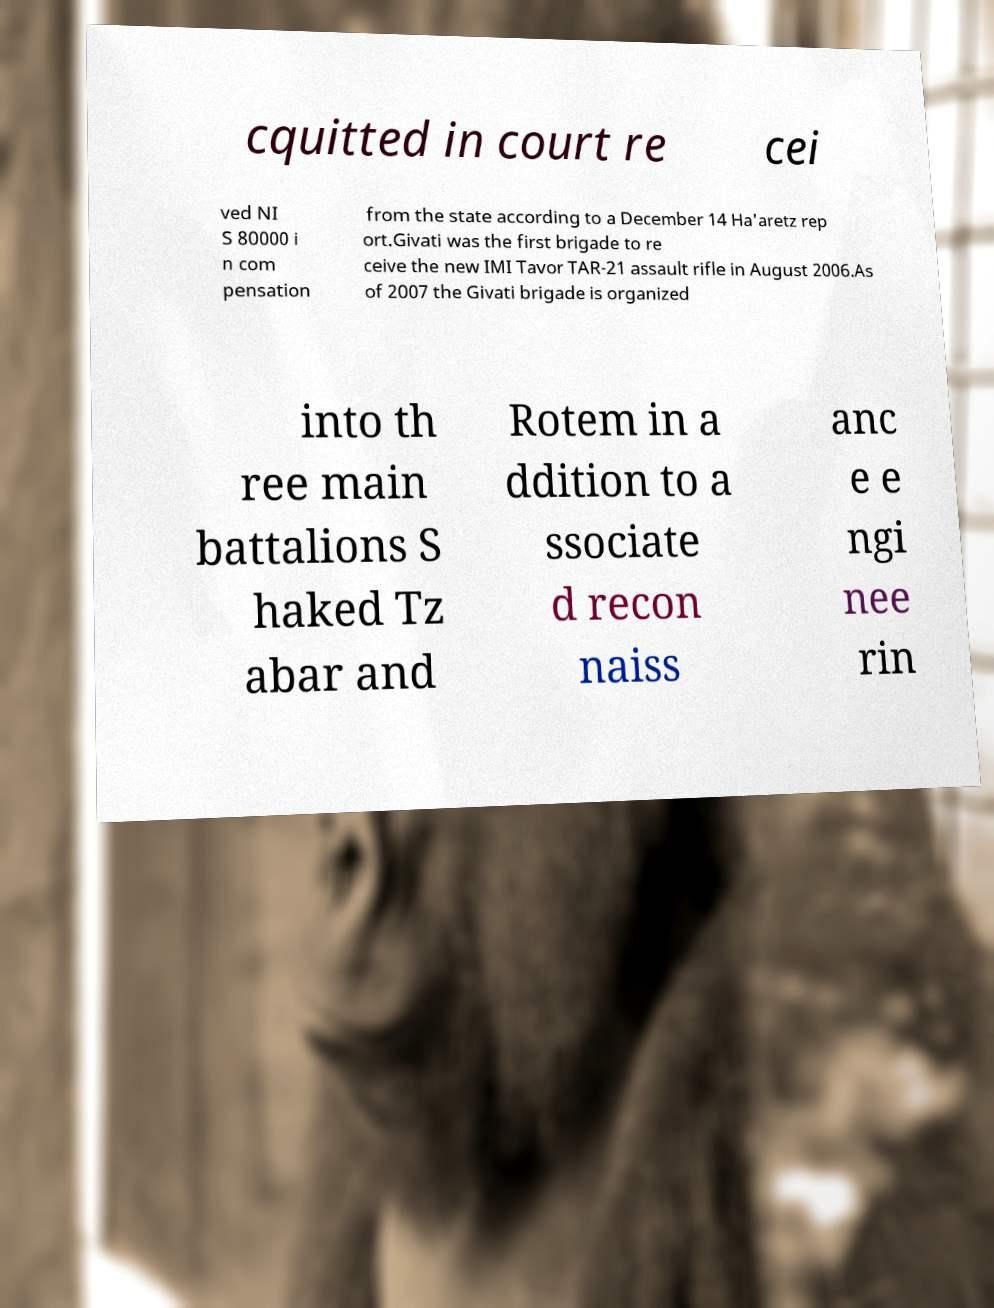Can you accurately transcribe the text from the provided image for me? cquitted in court re cei ved NI S 80000 i n com pensation from the state according to a December 14 Ha'aretz rep ort.Givati was the first brigade to re ceive the new IMI Tavor TAR-21 assault rifle in August 2006.As of 2007 the Givati brigade is organized into th ree main battalions S haked Tz abar and Rotem in a ddition to a ssociate d recon naiss anc e e ngi nee rin 